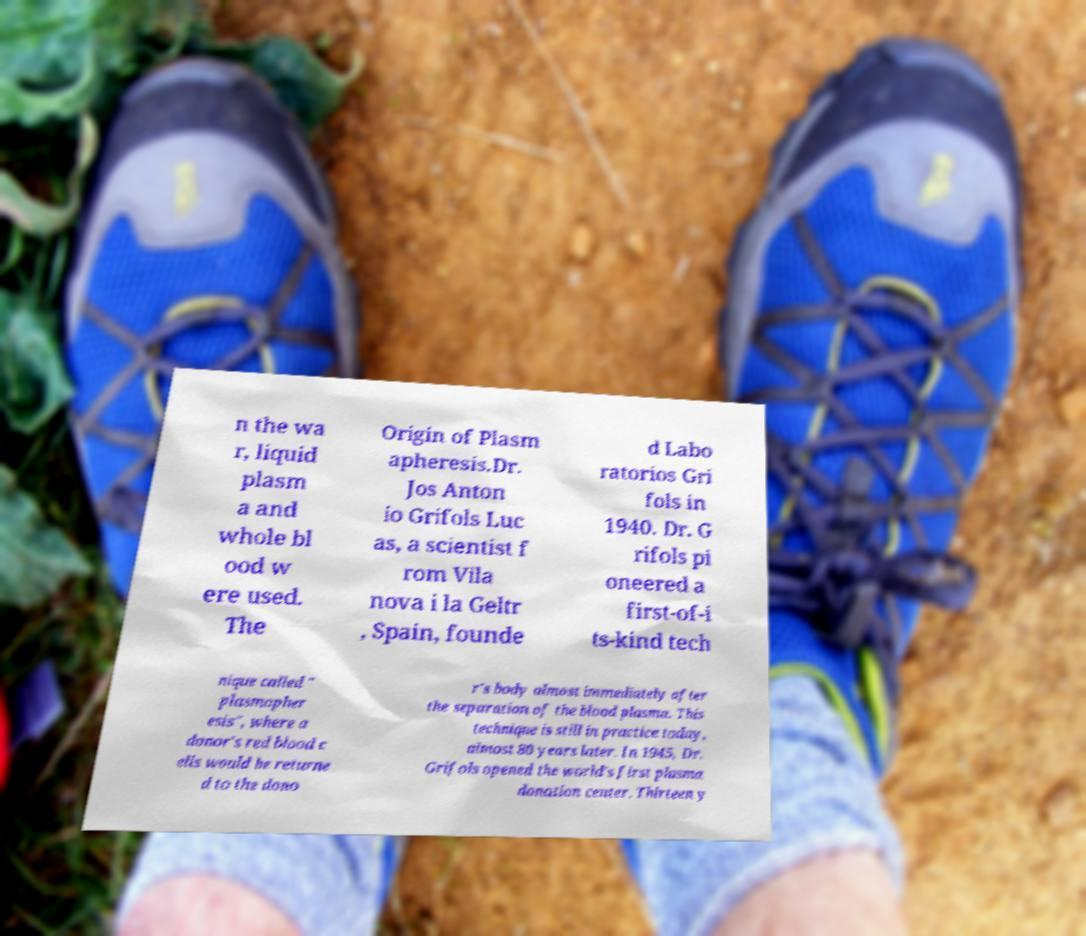There's text embedded in this image that I need extracted. Can you transcribe it verbatim? n the wa r, liquid plasm a and whole bl ood w ere used. The Origin of Plasm apheresis.Dr. Jos Anton io Grifols Luc as, a scientist f rom Vila nova i la Geltr , Spain, founde d Labo ratorios Gri fols in 1940. Dr. G rifols pi oneered a first-of-i ts-kind tech nique called " plasmapher esis", where a donor's red blood c ells would be returne d to the dono r's body almost immediately after the separation of the blood plasma. This technique is still in practice today, almost 80 years later. In 1945, Dr. Grifols opened the world's first plasma donation center. Thirteen y 